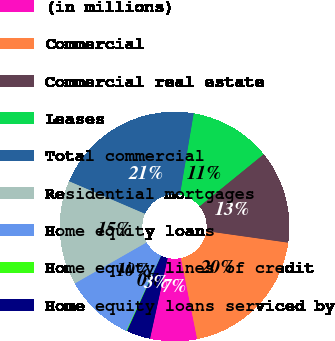<chart> <loc_0><loc_0><loc_500><loc_500><pie_chart><fcel>(in millions)<fcel>Commercial<fcel>Commercial real estate<fcel>Leases<fcel>Total commercial<fcel>Residential mortgages<fcel>Home equity loans<fcel>Home equity lines of credit<fcel>Home equity loans serviced by<nl><fcel>6.6%<fcel>19.6%<fcel>13.1%<fcel>11.47%<fcel>21.22%<fcel>14.72%<fcel>9.85%<fcel>0.1%<fcel>3.35%<nl></chart> 